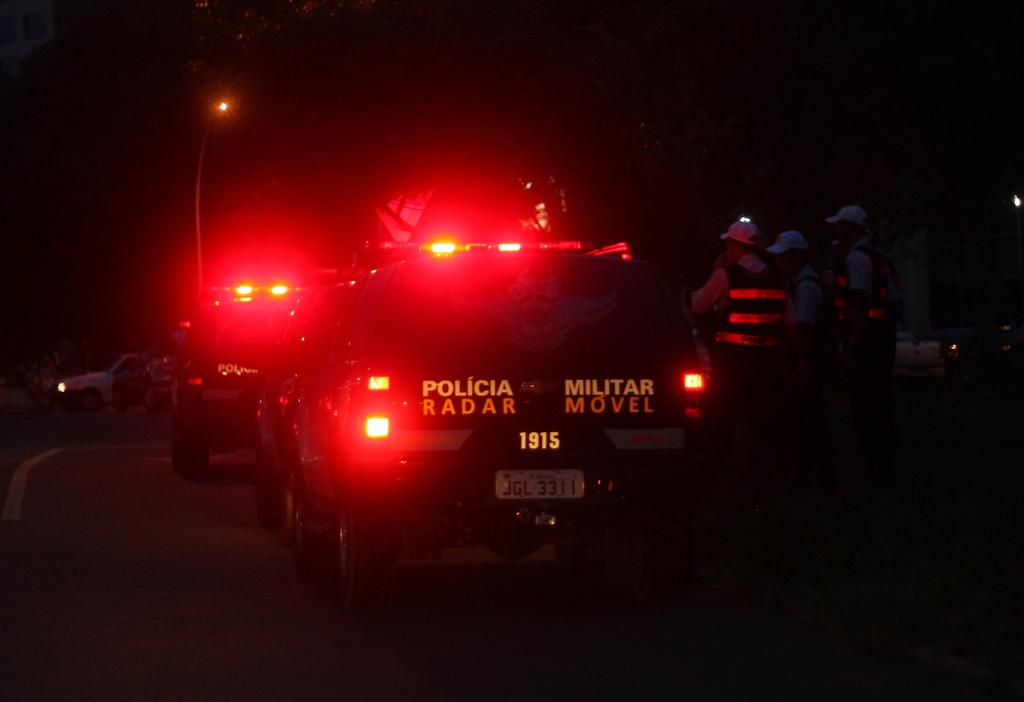What is the main object in the image? There is a street light in the image. What else can be seen in the image besides the street light? There are vehicles and three persons standing on the road. How would you describe the lighting conditions in the image? The background of the image is dark. Can you tell me how many giraffes are standing on the shelf in the image? There are no giraffes or shelves present in the image. 